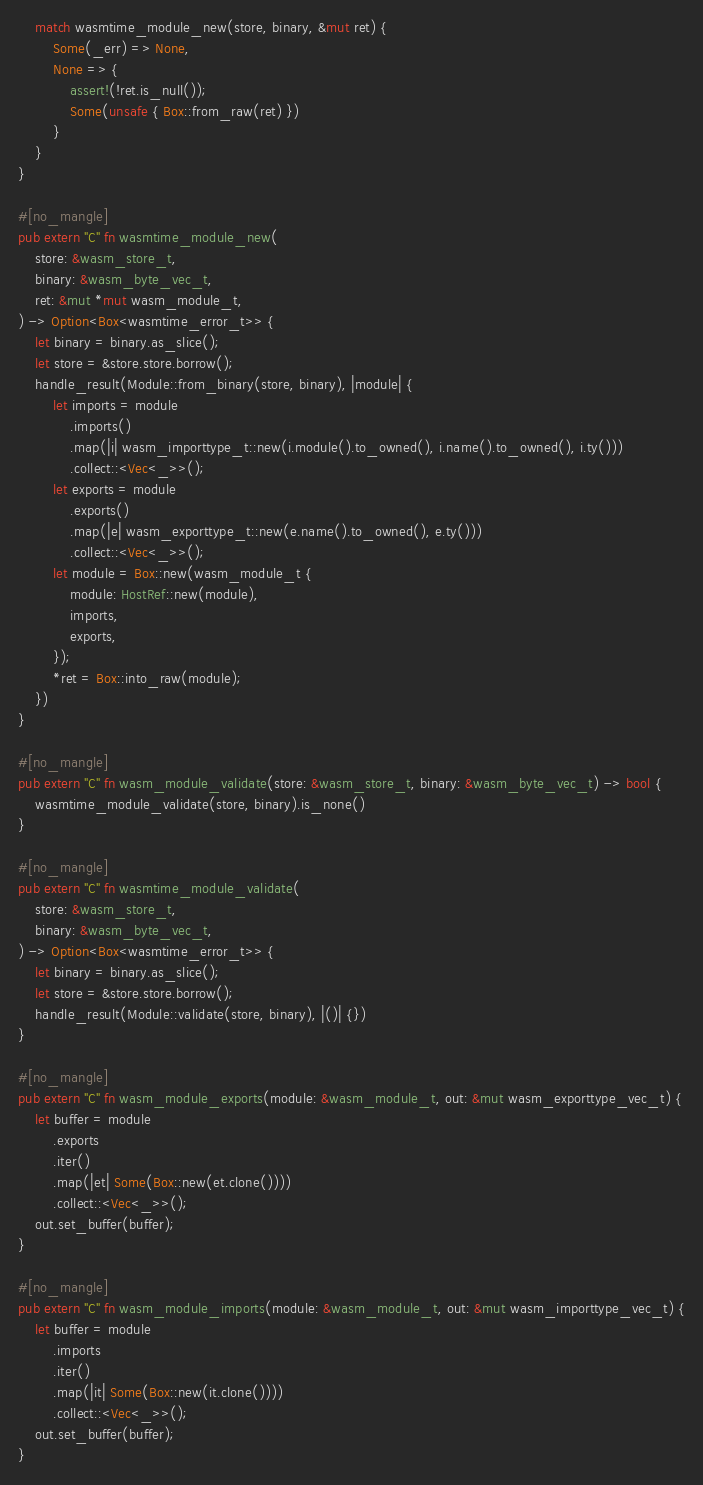<code> <loc_0><loc_0><loc_500><loc_500><_Rust_>    match wasmtime_module_new(store, binary, &mut ret) {
        Some(_err) => None,
        None => {
            assert!(!ret.is_null());
            Some(unsafe { Box::from_raw(ret) })
        }
    }
}

#[no_mangle]
pub extern "C" fn wasmtime_module_new(
    store: &wasm_store_t,
    binary: &wasm_byte_vec_t,
    ret: &mut *mut wasm_module_t,
) -> Option<Box<wasmtime_error_t>> {
    let binary = binary.as_slice();
    let store = &store.store.borrow();
    handle_result(Module::from_binary(store, binary), |module| {
        let imports = module
            .imports()
            .map(|i| wasm_importtype_t::new(i.module().to_owned(), i.name().to_owned(), i.ty()))
            .collect::<Vec<_>>();
        let exports = module
            .exports()
            .map(|e| wasm_exporttype_t::new(e.name().to_owned(), e.ty()))
            .collect::<Vec<_>>();
        let module = Box::new(wasm_module_t {
            module: HostRef::new(module),
            imports,
            exports,
        });
        *ret = Box::into_raw(module);
    })
}

#[no_mangle]
pub extern "C" fn wasm_module_validate(store: &wasm_store_t, binary: &wasm_byte_vec_t) -> bool {
    wasmtime_module_validate(store, binary).is_none()
}

#[no_mangle]
pub extern "C" fn wasmtime_module_validate(
    store: &wasm_store_t,
    binary: &wasm_byte_vec_t,
) -> Option<Box<wasmtime_error_t>> {
    let binary = binary.as_slice();
    let store = &store.store.borrow();
    handle_result(Module::validate(store, binary), |()| {})
}

#[no_mangle]
pub extern "C" fn wasm_module_exports(module: &wasm_module_t, out: &mut wasm_exporttype_vec_t) {
    let buffer = module
        .exports
        .iter()
        .map(|et| Some(Box::new(et.clone())))
        .collect::<Vec<_>>();
    out.set_buffer(buffer);
}

#[no_mangle]
pub extern "C" fn wasm_module_imports(module: &wasm_module_t, out: &mut wasm_importtype_vec_t) {
    let buffer = module
        .imports
        .iter()
        .map(|it| Some(Box::new(it.clone())))
        .collect::<Vec<_>>();
    out.set_buffer(buffer);
}
</code> 